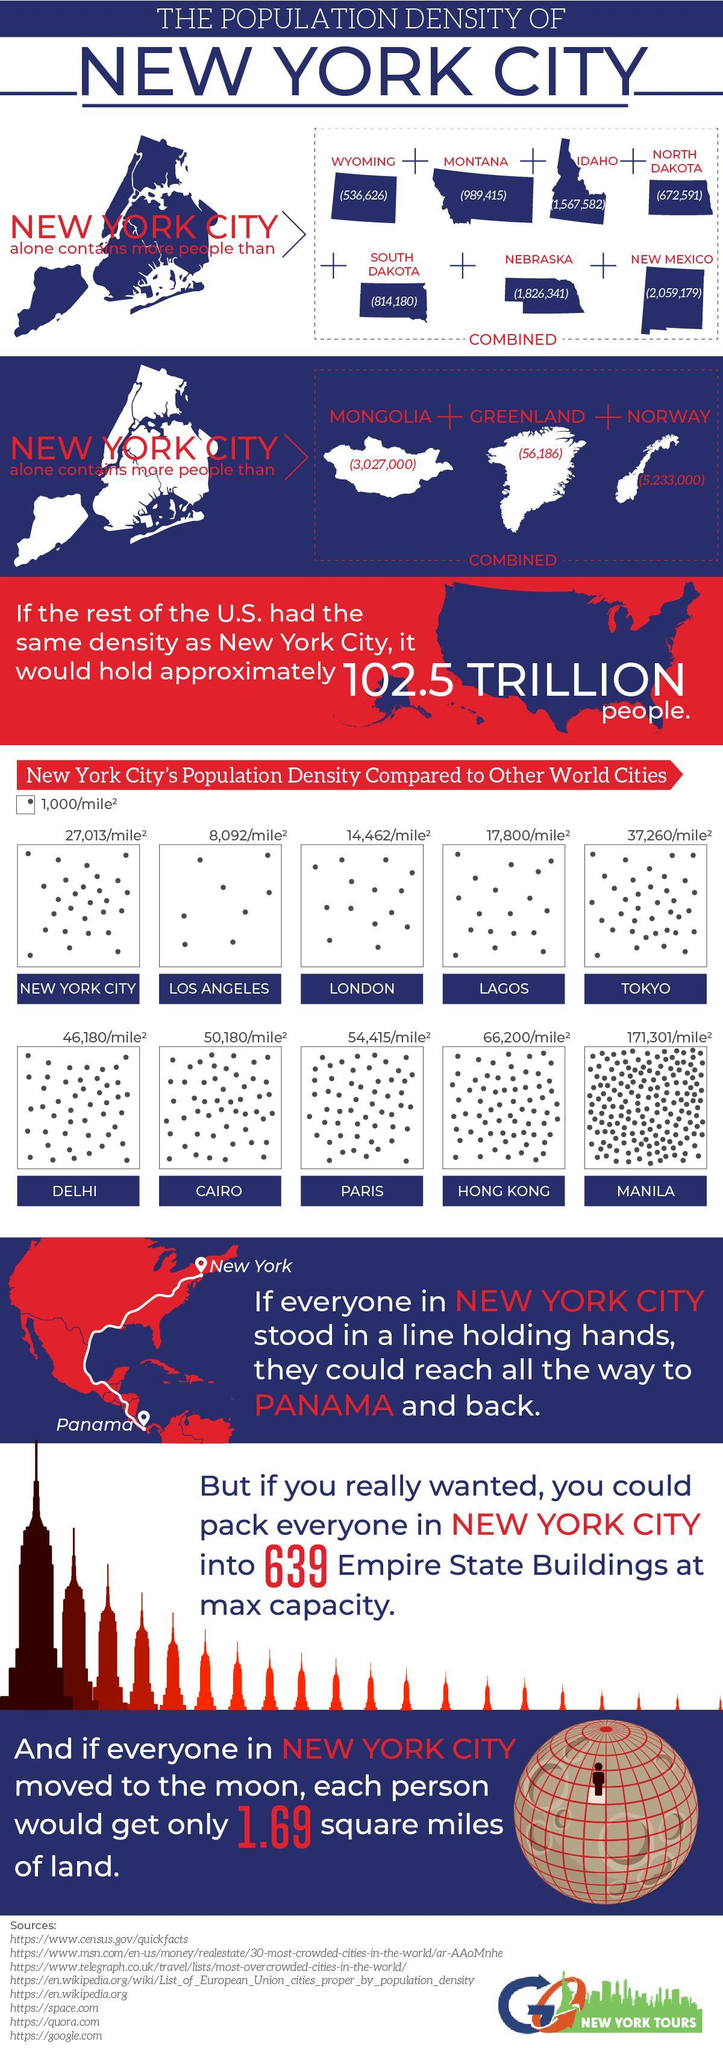Which is the second-least densely populated city?
Answer the question with a short phrase. Los Angeles Which is the second-most densely populated city? Hong Kong 